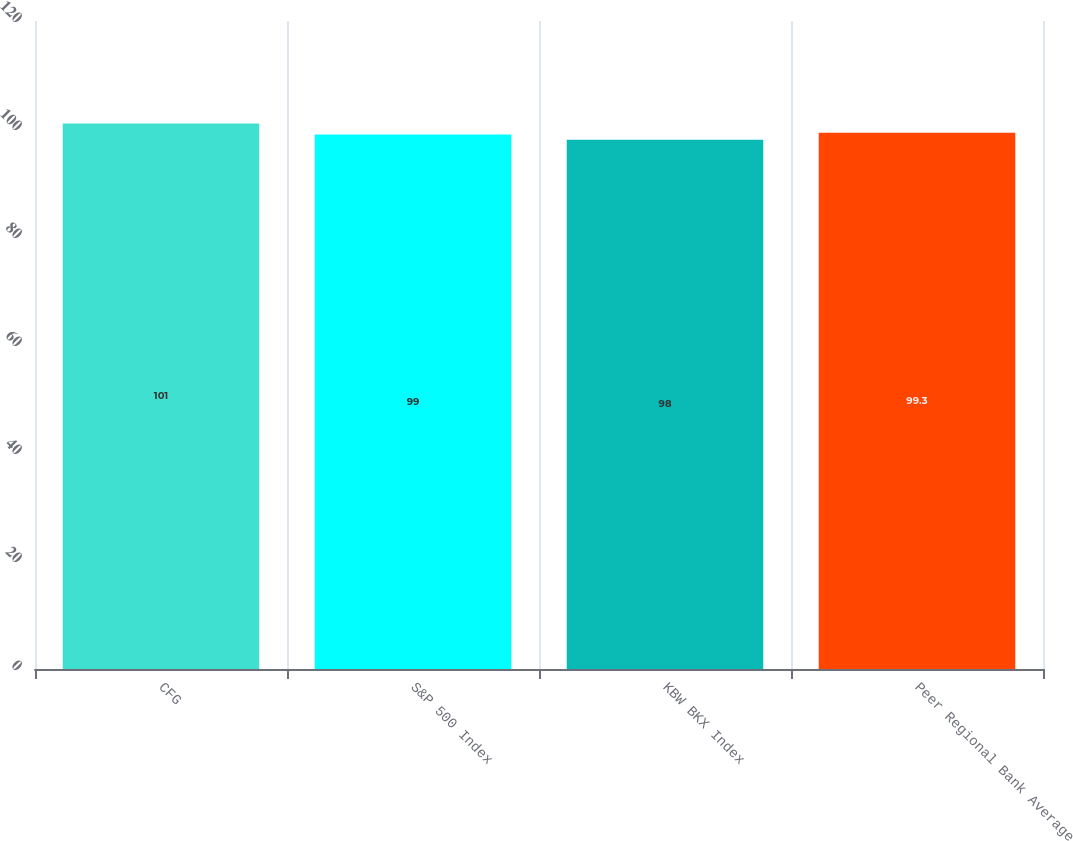<chart> <loc_0><loc_0><loc_500><loc_500><bar_chart><fcel>CFG<fcel>S&P 500 Index<fcel>KBW BKX Index<fcel>Peer Regional Bank Average<nl><fcel>101<fcel>99<fcel>98<fcel>99.3<nl></chart> 